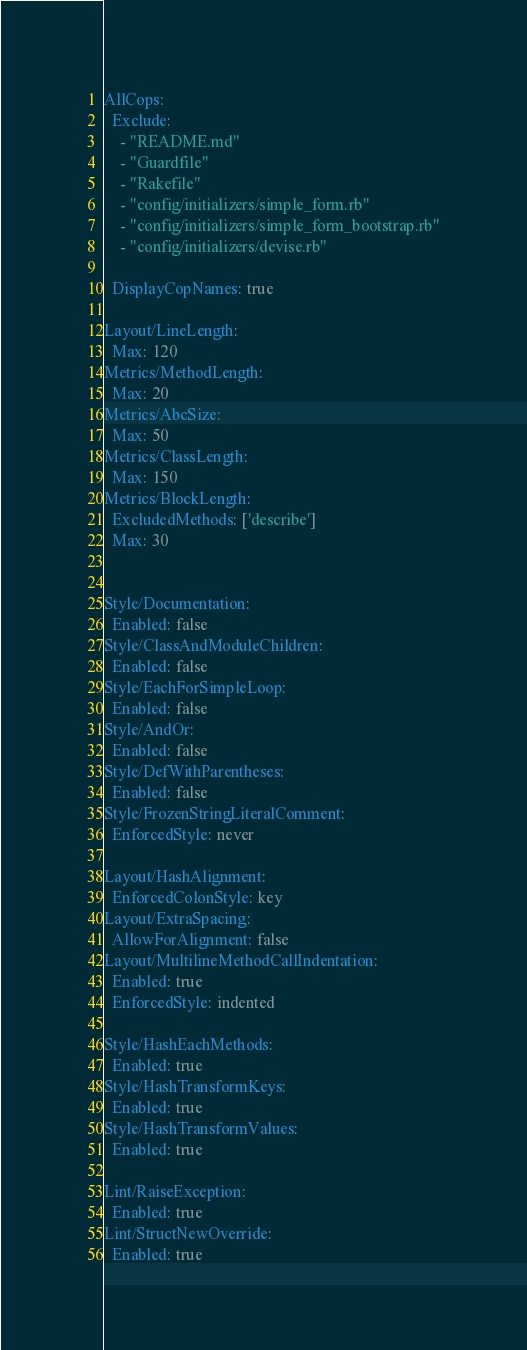<code> <loc_0><loc_0><loc_500><loc_500><_YAML_>AllCops:
  Exclude:
    - "README.md"
    - "Guardfile"
    - "Rakefile"
    - "config/initializers/simple_form.rb"
    - "config/initializers/simple_form_bootstrap.rb"
    - "config/initializers/devise.rb"

  DisplayCopNames: true

Layout/LineLength:
  Max: 120
Metrics/MethodLength:
  Max: 20
Metrics/AbcSize:
  Max: 50
Metrics/ClassLength:
  Max: 150
Metrics/BlockLength:
  ExcludedMethods: ['describe']
  Max: 30


Style/Documentation:
  Enabled: false
Style/ClassAndModuleChildren:
  Enabled: false
Style/EachForSimpleLoop:
  Enabled: false
Style/AndOr:
  Enabled: false
Style/DefWithParentheses:
  Enabled: false
Style/FrozenStringLiteralComment:
  EnforcedStyle: never

Layout/HashAlignment:
  EnforcedColonStyle: key
Layout/ExtraSpacing:
  AllowForAlignment: false
Layout/MultilineMethodCallIndentation:
  Enabled: true
  EnforcedStyle: indented

Style/HashEachMethods:
  Enabled: true
Style/HashTransformKeys:
  Enabled: true
Style/HashTransformValues:
  Enabled: true

Lint/RaiseException:
  Enabled: true
Lint/StructNewOverride:
  Enabled: true
</code> 